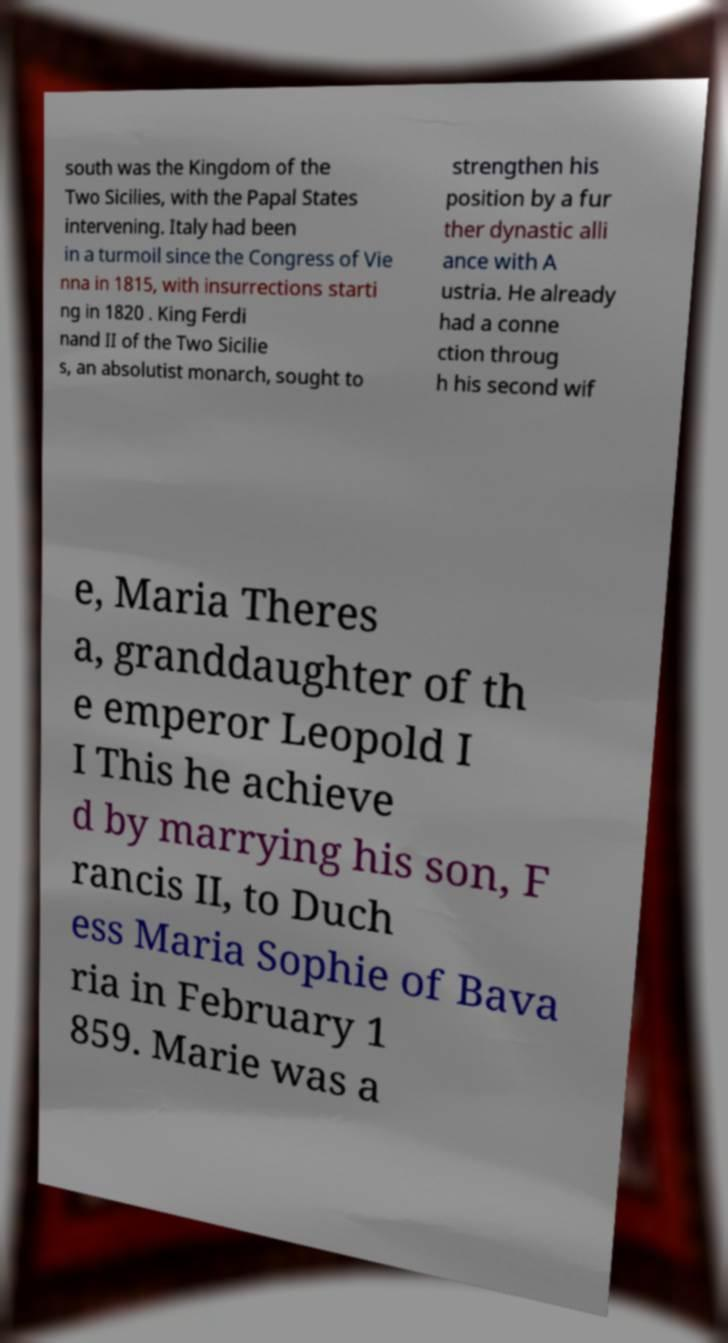There's text embedded in this image that I need extracted. Can you transcribe it verbatim? south was the Kingdom of the Two Sicilies, with the Papal States intervening. Italy had been in a turmoil since the Congress of Vie nna in 1815, with insurrections starti ng in 1820 . King Ferdi nand II of the Two Sicilie s, an absolutist monarch, sought to strengthen his position by a fur ther dynastic alli ance with A ustria. He already had a conne ction throug h his second wif e, Maria Theres a, granddaughter of th e emperor Leopold I I This he achieve d by marrying his son, F rancis II, to Duch ess Maria Sophie of Bava ria in February 1 859. Marie was a 